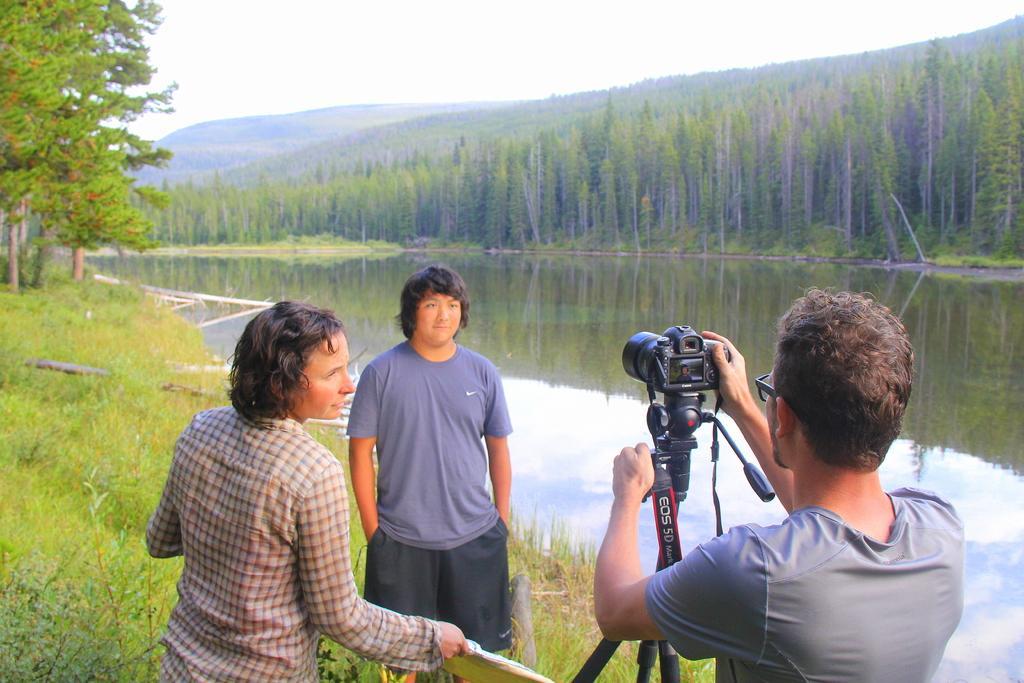How would you summarize this image in a sentence or two? On the right side, there is a person in gray color T-shirt, holding the camera with one hand, which is on a stand and there is a river. On the left side, there is a person in a shirt, holding an object and standing and their grass on the ground. Beside this person, there is a person in a T-shirt, standing. In the background, there are trees and there are clouds in the sky. 